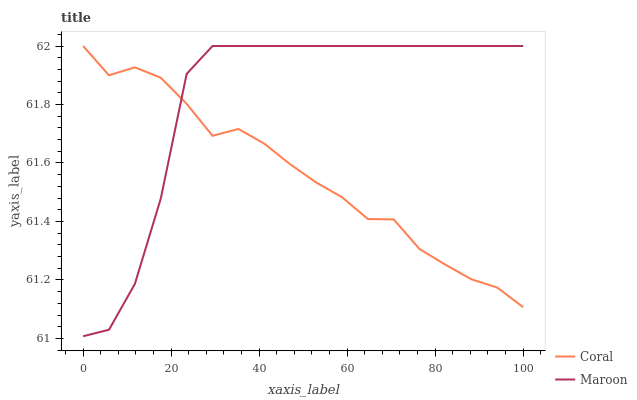Does Coral have the minimum area under the curve?
Answer yes or no. Yes. Does Maroon have the maximum area under the curve?
Answer yes or no. Yes. Does Maroon have the minimum area under the curve?
Answer yes or no. No. Is Coral the smoothest?
Answer yes or no. Yes. Is Maroon the roughest?
Answer yes or no. Yes. Is Maroon the smoothest?
Answer yes or no. No. Does Maroon have the highest value?
Answer yes or no. Yes. Does Coral intersect Maroon?
Answer yes or no. Yes. Is Coral less than Maroon?
Answer yes or no. No. Is Coral greater than Maroon?
Answer yes or no. No. 